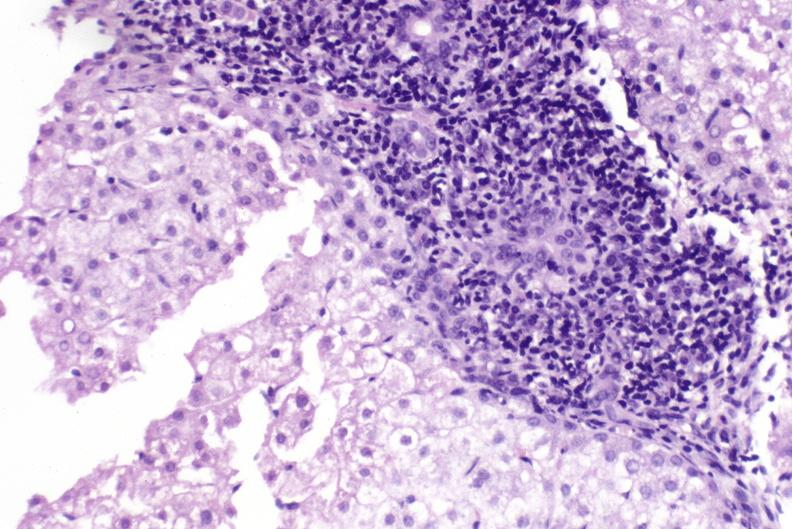s liver present?
Answer the question using a single word or phrase. Yes 